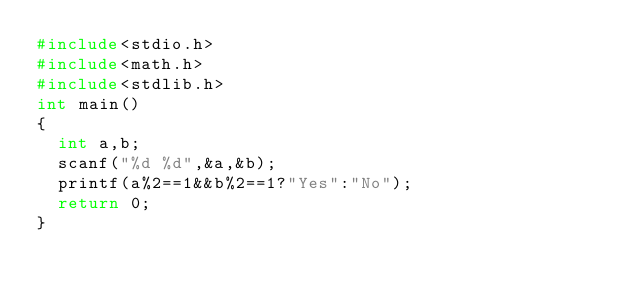Convert code to text. <code><loc_0><loc_0><loc_500><loc_500><_C_>#include<stdio.h>
#include<math.h>
#include<stdlib.h>
int main()
{
  int a,b;
  scanf("%d %d",&a,&b);
  printf(a%2==1&&b%2==1?"Yes":"No");
  return 0;
}</code> 